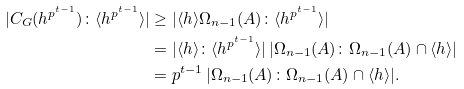<formula> <loc_0><loc_0><loc_500><loc_500>| C _ { G } ( h ^ { p ^ { t - 1 } } ) \colon \langle h ^ { p ^ { t - 1 } } \rangle | & \geq | \langle h \rangle \Omega _ { n - 1 } ( A ) \colon \langle h ^ { p ^ { t - 1 } } \rangle | \\ & = | \langle h \rangle \colon \langle h ^ { p ^ { t - 1 } } \rangle | \, | \Omega _ { n - 1 } ( A ) \colon \Omega _ { n - 1 } ( A ) \cap \langle h \rangle | \\ & = p ^ { t - 1 } \, | \Omega _ { n - 1 } ( A ) \colon \Omega _ { n - 1 } ( A ) \cap \langle h \rangle | .</formula> 